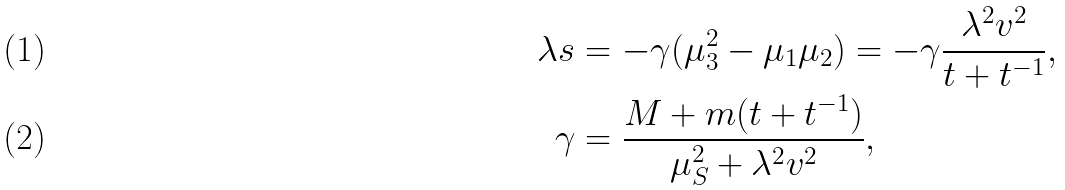Convert formula to latex. <formula><loc_0><loc_0><loc_500><loc_500>\lambda s & = - \gamma ( \mu _ { 3 } ^ { 2 } - \mu _ { 1 } \mu _ { 2 } ) = - \gamma \frac { \lambda ^ { 2 } v ^ { 2 } } { t + t ^ { - 1 } } , \\ \gamma & = \frac { M + m ( t + t ^ { - 1 } ) } { \mu _ { S } ^ { 2 } + \lambda ^ { 2 } v ^ { 2 } } ,</formula> 